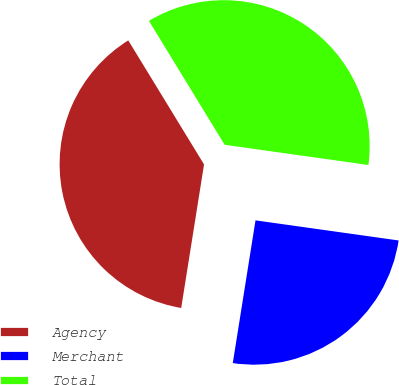Convert chart to OTSL. <chart><loc_0><loc_0><loc_500><loc_500><pie_chart><fcel>Agency<fcel>Merchant<fcel>Total<nl><fcel>38.76%<fcel>25.29%<fcel>35.95%<nl></chart> 